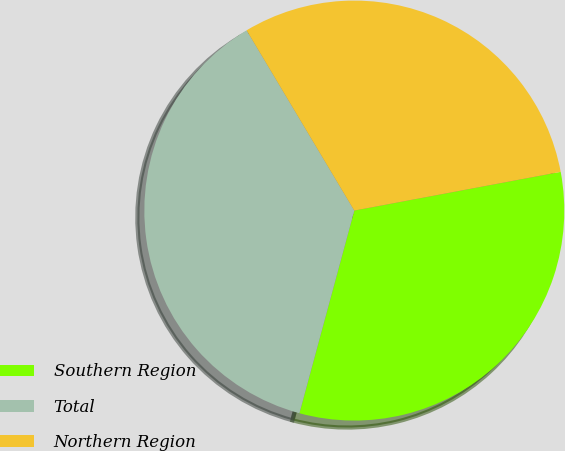<chart> <loc_0><loc_0><loc_500><loc_500><pie_chart><fcel>Southern Region<fcel>Total<fcel>Northern Region<nl><fcel>32.16%<fcel>37.22%<fcel>30.62%<nl></chart> 